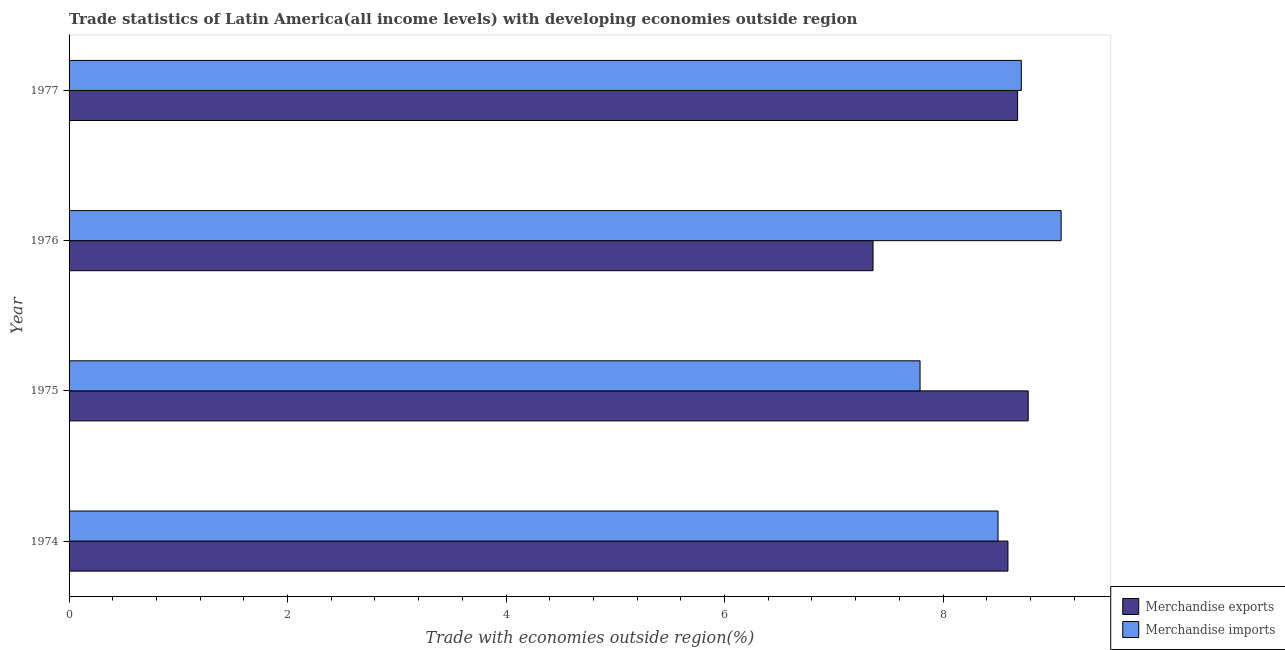How many different coloured bars are there?
Provide a succinct answer. 2. How many groups of bars are there?
Give a very brief answer. 4. Are the number of bars per tick equal to the number of legend labels?
Your answer should be compact. Yes. How many bars are there on the 4th tick from the bottom?
Your response must be concise. 2. What is the label of the 4th group of bars from the top?
Provide a short and direct response. 1974. In how many cases, is the number of bars for a given year not equal to the number of legend labels?
Provide a succinct answer. 0. What is the merchandise exports in 1976?
Offer a terse response. 7.36. Across all years, what is the maximum merchandise imports?
Ensure brevity in your answer.  9.08. Across all years, what is the minimum merchandise exports?
Give a very brief answer. 7.36. In which year was the merchandise exports maximum?
Give a very brief answer. 1975. In which year was the merchandise exports minimum?
Provide a succinct answer. 1976. What is the total merchandise exports in the graph?
Your answer should be compact. 33.42. What is the difference between the merchandise imports in 1975 and that in 1976?
Provide a succinct answer. -1.29. What is the difference between the merchandise imports in 1975 and the merchandise exports in 1976?
Make the answer very short. 0.43. What is the average merchandise imports per year?
Provide a short and direct response. 8.52. In the year 1976, what is the difference between the merchandise imports and merchandise exports?
Offer a terse response. 1.72. What is the ratio of the merchandise exports in 1974 to that in 1976?
Give a very brief answer. 1.17. Is the difference between the merchandise imports in 1974 and 1975 greater than the difference between the merchandise exports in 1974 and 1975?
Offer a very short reply. Yes. What is the difference between the highest and the second highest merchandise imports?
Your answer should be very brief. 0.36. What is the difference between the highest and the lowest merchandise imports?
Your answer should be compact. 1.29. What does the 2nd bar from the bottom in 1976 represents?
Keep it short and to the point. Merchandise imports. How many bars are there?
Keep it short and to the point. 8. How many years are there in the graph?
Make the answer very short. 4. Are the values on the major ticks of X-axis written in scientific E-notation?
Provide a succinct answer. No. Does the graph contain any zero values?
Offer a terse response. No. Does the graph contain grids?
Offer a terse response. No. Where does the legend appear in the graph?
Ensure brevity in your answer.  Bottom right. How many legend labels are there?
Give a very brief answer. 2. What is the title of the graph?
Offer a very short reply. Trade statistics of Latin America(all income levels) with developing economies outside region. What is the label or title of the X-axis?
Offer a terse response. Trade with economies outside region(%). What is the Trade with economies outside region(%) in Merchandise exports in 1974?
Make the answer very short. 8.59. What is the Trade with economies outside region(%) in Merchandise imports in 1974?
Your answer should be very brief. 8.5. What is the Trade with economies outside region(%) of Merchandise exports in 1975?
Provide a succinct answer. 8.78. What is the Trade with economies outside region(%) in Merchandise imports in 1975?
Keep it short and to the point. 7.79. What is the Trade with economies outside region(%) in Merchandise exports in 1976?
Provide a succinct answer. 7.36. What is the Trade with economies outside region(%) in Merchandise imports in 1976?
Ensure brevity in your answer.  9.08. What is the Trade with economies outside region(%) in Merchandise exports in 1977?
Provide a short and direct response. 8.68. What is the Trade with economies outside region(%) of Merchandise imports in 1977?
Your answer should be very brief. 8.72. Across all years, what is the maximum Trade with economies outside region(%) in Merchandise exports?
Make the answer very short. 8.78. Across all years, what is the maximum Trade with economies outside region(%) of Merchandise imports?
Keep it short and to the point. 9.08. Across all years, what is the minimum Trade with economies outside region(%) in Merchandise exports?
Ensure brevity in your answer.  7.36. Across all years, what is the minimum Trade with economies outside region(%) in Merchandise imports?
Your answer should be compact. 7.79. What is the total Trade with economies outside region(%) of Merchandise exports in the graph?
Make the answer very short. 33.42. What is the total Trade with economies outside region(%) in Merchandise imports in the graph?
Your response must be concise. 34.09. What is the difference between the Trade with economies outside region(%) in Merchandise exports in 1974 and that in 1975?
Provide a short and direct response. -0.19. What is the difference between the Trade with economies outside region(%) in Merchandise imports in 1974 and that in 1975?
Your response must be concise. 0.71. What is the difference between the Trade with economies outside region(%) of Merchandise exports in 1974 and that in 1976?
Your response must be concise. 1.23. What is the difference between the Trade with economies outside region(%) in Merchandise imports in 1974 and that in 1976?
Give a very brief answer. -0.58. What is the difference between the Trade with economies outside region(%) in Merchandise exports in 1974 and that in 1977?
Your answer should be very brief. -0.09. What is the difference between the Trade with economies outside region(%) of Merchandise imports in 1974 and that in 1977?
Your answer should be compact. -0.21. What is the difference between the Trade with economies outside region(%) in Merchandise exports in 1975 and that in 1976?
Your response must be concise. 1.42. What is the difference between the Trade with economies outside region(%) of Merchandise imports in 1975 and that in 1976?
Make the answer very short. -1.29. What is the difference between the Trade with economies outside region(%) of Merchandise exports in 1975 and that in 1977?
Keep it short and to the point. 0.1. What is the difference between the Trade with economies outside region(%) in Merchandise imports in 1975 and that in 1977?
Provide a short and direct response. -0.93. What is the difference between the Trade with economies outside region(%) in Merchandise exports in 1976 and that in 1977?
Make the answer very short. -1.32. What is the difference between the Trade with economies outside region(%) in Merchandise imports in 1976 and that in 1977?
Provide a short and direct response. 0.36. What is the difference between the Trade with economies outside region(%) in Merchandise exports in 1974 and the Trade with economies outside region(%) in Merchandise imports in 1975?
Offer a very short reply. 0.8. What is the difference between the Trade with economies outside region(%) in Merchandise exports in 1974 and the Trade with economies outside region(%) in Merchandise imports in 1976?
Provide a succinct answer. -0.49. What is the difference between the Trade with economies outside region(%) in Merchandise exports in 1974 and the Trade with economies outside region(%) in Merchandise imports in 1977?
Offer a terse response. -0.12. What is the difference between the Trade with economies outside region(%) of Merchandise exports in 1975 and the Trade with economies outside region(%) of Merchandise imports in 1976?
Your answer should be very brief. -0.3. What is the difference between the Trade with economies outside region(%) of Merchandise exports in 1975 and the Trade with economies outside region(%) of Merchandise imports in 1977?
Give a very brief answer. 0.06. What is the difference between the Trade with economies outside region(%) in Merchandise exports in 1976 and the Trade with economies outside region(%) in Merchandise imports in 1977?
Keep it short and to the point. -1.36. What is the average Trade with economies outside region(%) in Merchandise exports per year?
Your answer should be compact. 8.35. What is the average Trade with economies outside region(%) of Merchandise imports per year?
Keep it short and to the point. 8.52. In the year 1974, what is the difference between the Trade with economies outside region(%) in Merchandise exports and Trade with economies outside region(%) in Merchandise imports?
Offer a very short reply. 0.09. In the year 1976, what is the difference between the Trade with economies outside region(%) in Merchandise exports and Trade with economies outside region(%) in Merchandise imports?
Offer a terse response. -1.72. In the year 1977, what is the difference between the Trade with economies outside region(%) of Merchandise exports and Trade with economies outside region(%) of Merchandise imports?
Offer a terse response. -0.03. What is the ratio of the Trade with economies outside region(%) of Merchandise exports in 1974 to that in 1975?
Provide a short and direct response. 0.98. What is the ratio of the Trade with economies outside region(%) of Merchandise imports in 1974 to that in 1975?
Give a very brief answer. 1.09. What is the ratio of the Trade with economies outside region(%) in Merchandise exports in 1974 to that in 1976?
Make the answer very short. 1.17. What is the ratio of the Trade with economies outside region(%) in Merchandise imports in 1974 to that in 1976?
Ensure brevity in your answer.  0.94. What is the ratio of the Trade with economies outside region(%) of Merchandise imports in 1974 to that in 1977?
Provide a succinct answer. 0.98. What is the ratio of the Trade with economies outside region(%) of Merchandise exports in 1975 to that in 1976?
Keep it short and to the point. 1.19. What is the ratio of the Trade with economies outside region(%) of Merchandise imports in 1975 to that in 1976?
Offer a very short reply. 0.86. What is the ratio of the Trade with economies outside region(%) in Merchandise exports in 1975 to that in 1977?
Your answer should be very brief. 1.01. What is the ratio of the Trade with economies outside region(%) of Merchandise imports in 1975 to that in 1977?
Provide a succinct answer. 0.89. What is the ratio of the Trade with economies outside region(%) in Merchandise exports in 1976 to that in 1977?
Keep it short and to the point. 0.85. What is the ratio of the Trade with economies outside region(%) in Merchandise imports in 1976 to that in 1977?
Your answer should be compact. 1.04. What is the difference between the highest and the second highest Trade with economies outside region(%) in Merchandise exports?
Your answer should be compact. 0.1. What is the difference between the highest and the second highest Trade with economies outside region(%) in Merchandise imports?
Offer a terse response. 0.36. What is the difference between the highest and the lowest Trade with economies outside region(%) in Merchandise exports?
Keep it short and to the point. 1.42. What is the difference between the highest and the lowest Trade with economies outside region(%) of Merchandise imports?
Your response must be concise. 1.29. 